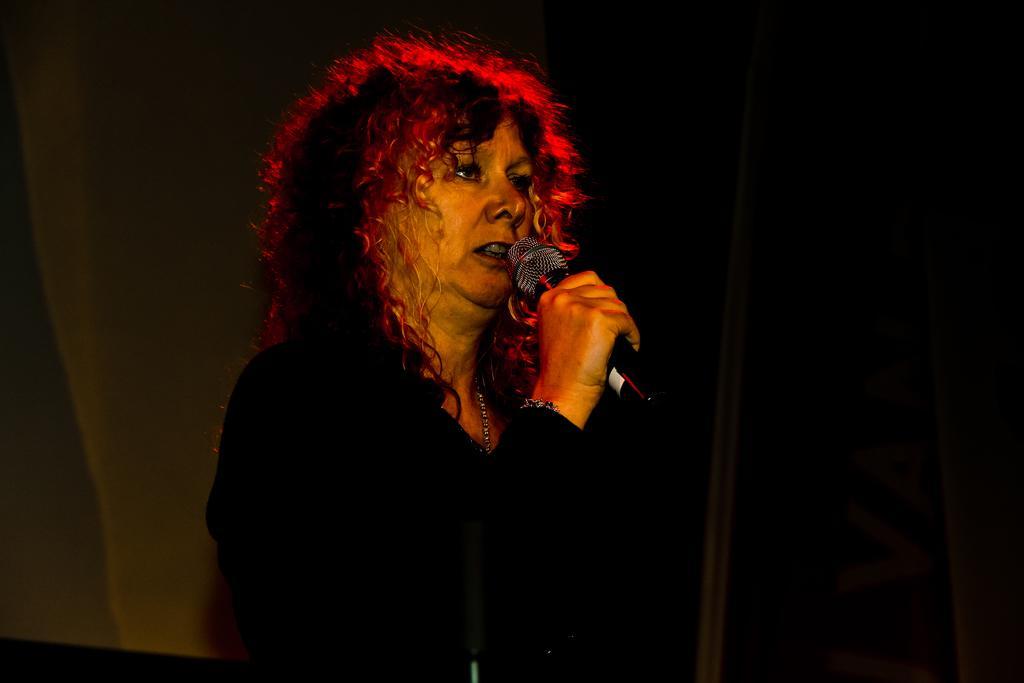Please provide a concise description of this image. In the foreground of this image, there is a woman holding a mic and the background image is not clear. 